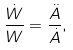<formula> <loc_0><loc_0><loc_500><loc_500>\frac { \dot { W } } { W } = \frac { \ddot { A } } { \dot { A } } ,</formula> 